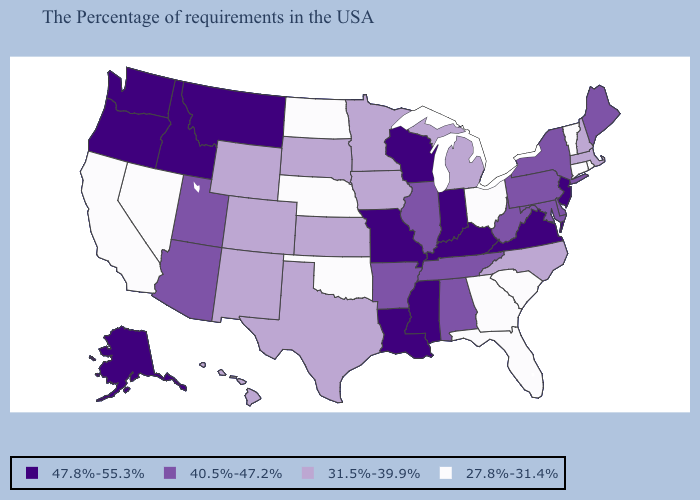What is the highest value in the USA?
Keep it brief. 47.8%-55.3%. Name the states that have a value in the range 47.8%-55.3%?
Concise answer only. New Jersey, Virginia, Kentucky, Indiana, Wisconsin, Mississippi, Louisiana, Missouri, Montana, Idaho, Washington, Oregon, Alaska. What is the value of New Hampshire?
Concise answer only. 31.5%-39.9%. What is the lowest value in the USA?
Give a very brief answer. 27.8%-31.4%. What is the highest value in states that border Washington?
Give a very brief answer. 47.8%-55.3%. Name the states that have a value in the range 47.8%-55.3%?
Answer briefly. New Jersey, Virginia, Kentucky, Indiana, Wisconsin, Mississippi, Louisiana, Missouri, Montana, Idaho, Washington, Oregon, Alaska. Among the states that border Georgia , does South Carolina have the lowest value?
Concise answer only. Yes. What is the lowest value in the Northeast?
Quick response, please. 27.8%-31.4%. What is the value of New York?
Answer briefly. 40.5%-47.2%. Does the map have missing data?
Keep it brief. No. Name the states that have a value in the range 40.5%-47.2%?
Short answer required. Maine, New York, Delaware, Maryland, Pennsylvania, West Virginia, Alabama, Tennessee, Illinois, Arkansas, Utah, Arizona. Does Oregon have the same value as Vermont?
Give a very brief answer. No. Which states have the lowest value in the USA?
Concise answer only. Rhode Island, Vermont, Connecticut, South Carolina, Ohio, Florida, Georgia, Nebraska, Oklahoma, North Dakota, Nevada, California. Does the map have missing data?
Short answer required. No. Name the states that have a value in the range 40.5%-47.2%?
Answer briefly. Maine, New York, Delaware, Maryland, Pennsylvania, West Virginia, Alabama, Tennessee, Illinois, Arkansas, Utah, Arizona. 